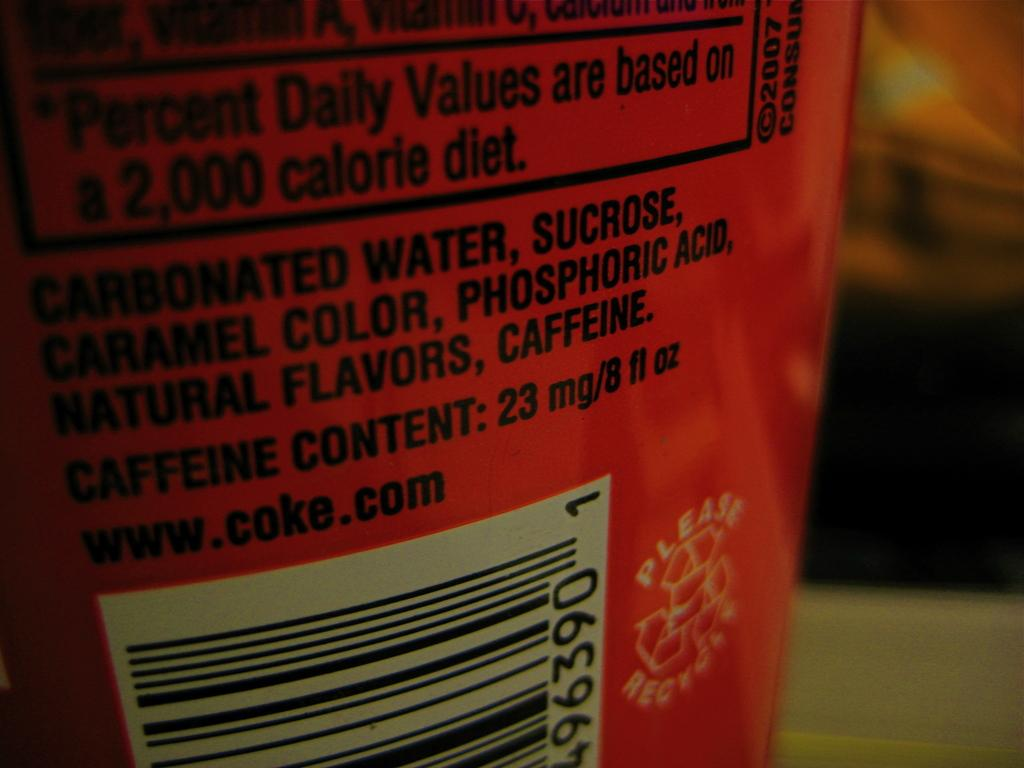<image>
Write a terse but informative summary of the picture. red sticker of beverage/ coke  with information of ingredients 